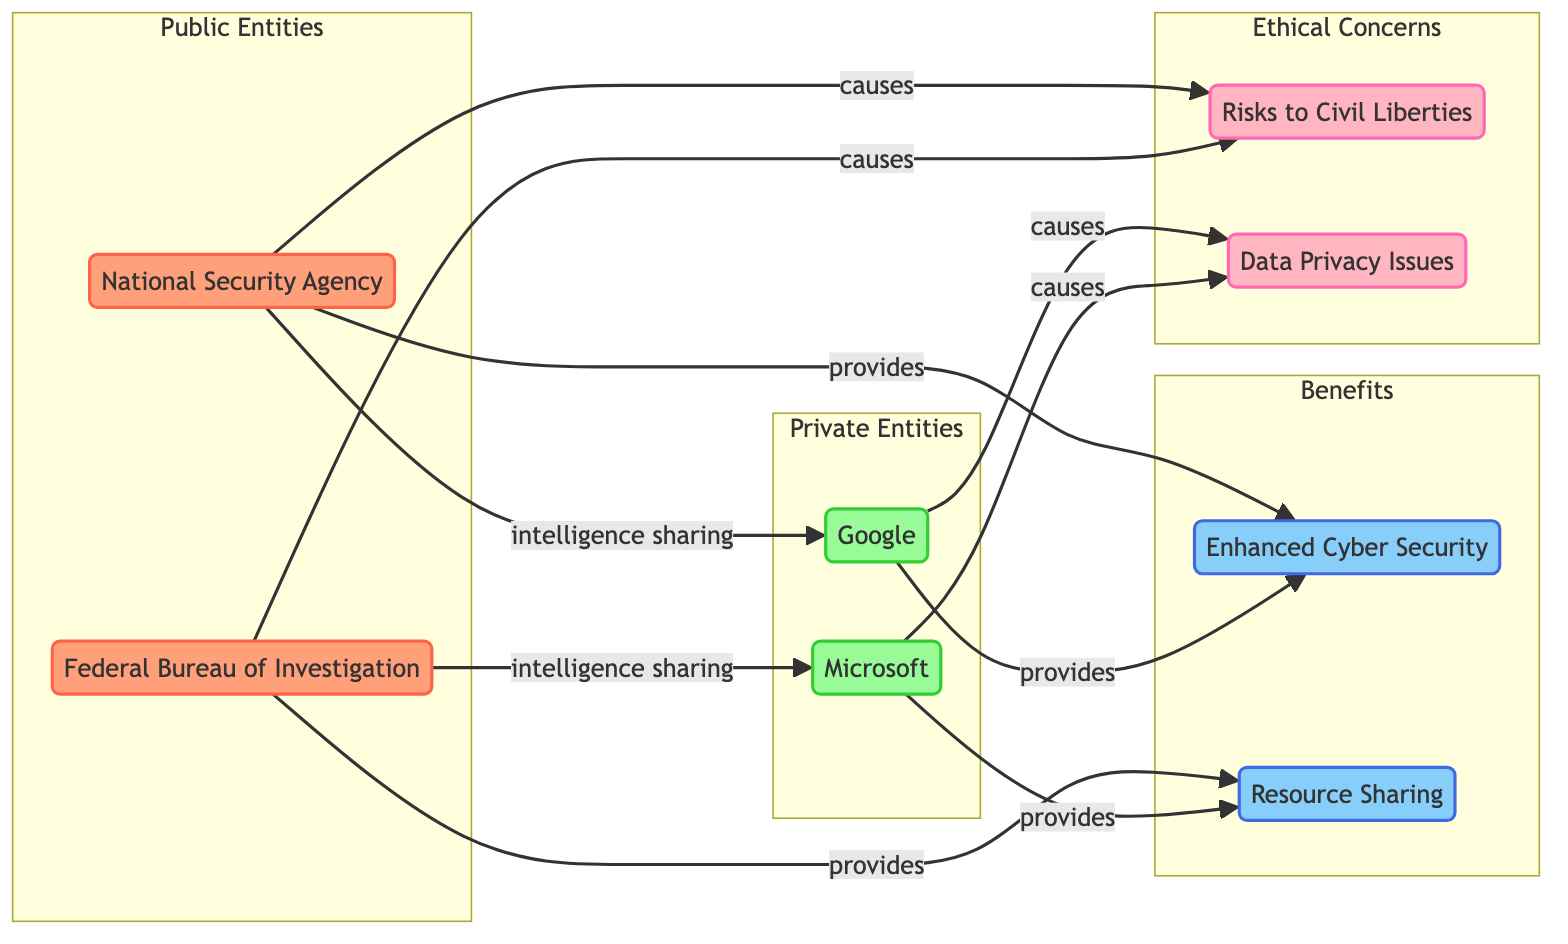What are the public entities depicted in the diagram? The diagram contains two nodes labeled as public entities: the National Security Agency (NSA) and the Federal Bureau of Investigation (FBI). These are explicitly identified as part of the Public Entities group.
Answer: National Security Agency (NSA), Federal Bureau of Investigation (FBI) How many private entities are represented in the diagram? There are two distinct private entities shown in the diagram that are part of the Private Entities group, which are Google and Microsoft. The count of these nodes gives the total number of private entities.
Answer: 2 What benefit does the National Security Agency provide? The node labeled "Enhanced Cyber Security" is connected to the National Security Agency (NSA) with a relationship labeled "provides." This indicates that the NSA provides enhanced cyber security.
Answer: Enhanced Cyber Security Which organization is linked to civil liberty risks? The diagram shows connections from both the National Security Agency (NSA) and the Federal Bureau of Investigation (FBI) to the node "Risks to Civil Liberties," indicating both organizations are linked to this concern.
Answer: National Security Agency, Federal Bureau of Investigation How many total edges are there in the diagram? By counting the connections from one node to another (edges), we find a total of 10 edges relating to intelligence sharing and providing benefits, as well as causing ethical concerns.
Answer: 10 What causes data privacy issues according to the diagram? The diagram shows that both Google and Microsoft cause data privacy issues, as directly indicated by the connections to the node labeled "Data Privacy Issues."
Answer: Google, Microsoft Which private entity does the Federal Bureau of Investigation share intelligence with? The edge labeled "intelligence sharing" connects the Federal Bureau of Investigation (FBI) to Microsoft, indicating that the FBI shares intelligence with this private entity.
Answer: Microsoft What aspect does resource sharing fall under in the diagram? Resource sharing is listed under the "Benefits" group in the diagram, highlighting it as an advantageous component of the public-private partnership in intelligence sharing.
Answer: Benefits What connection does Google have with ethical concerns in the diagram? Google is associated with the ethical concern of "Data Privacy Issues," as indicated by the directed edge that stems from Google to this node, denoting that Google's actions contribute to this issue.
Answer: Data Privacy Issues 